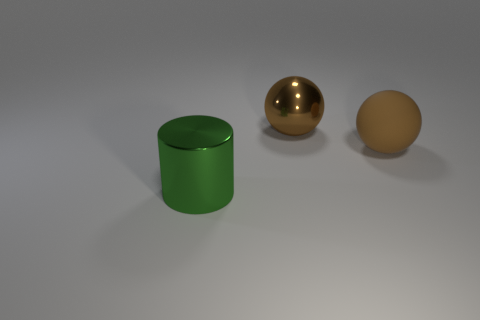Do the big green object and the brown metallic thing have the same shape?
Your answer should be very brief. No. Is there any other thing that has the same material as the cylinder?
Your response must be concise. Yes. The brown matte object has what size?
Offer a terse response. Large. What is the color of the object that is left of the large rubber thing and on the right side of the big cylinder?
Keep it short and to the point. Brown. Are there more small cyan rubber cubes than brown balls?
Provide a short and direct response. No. How many things are brown cubes or objects in front of the large brown metal thing?
Offer a very short reply. 2. Is the brown rubber thing the same size as the metal cylinder?
Your answer should be very brief. Yes. Are there any big brown rubber things on the right side of the large rubber object?
Offer a terse response. No. How big is the object that is both in front of the big metallic sphere and left of the large brown rubber ball?
Keep it short and to the point. Large. What number of objects are balls or large brown shiny things?
Give a very brief answer. 2. 